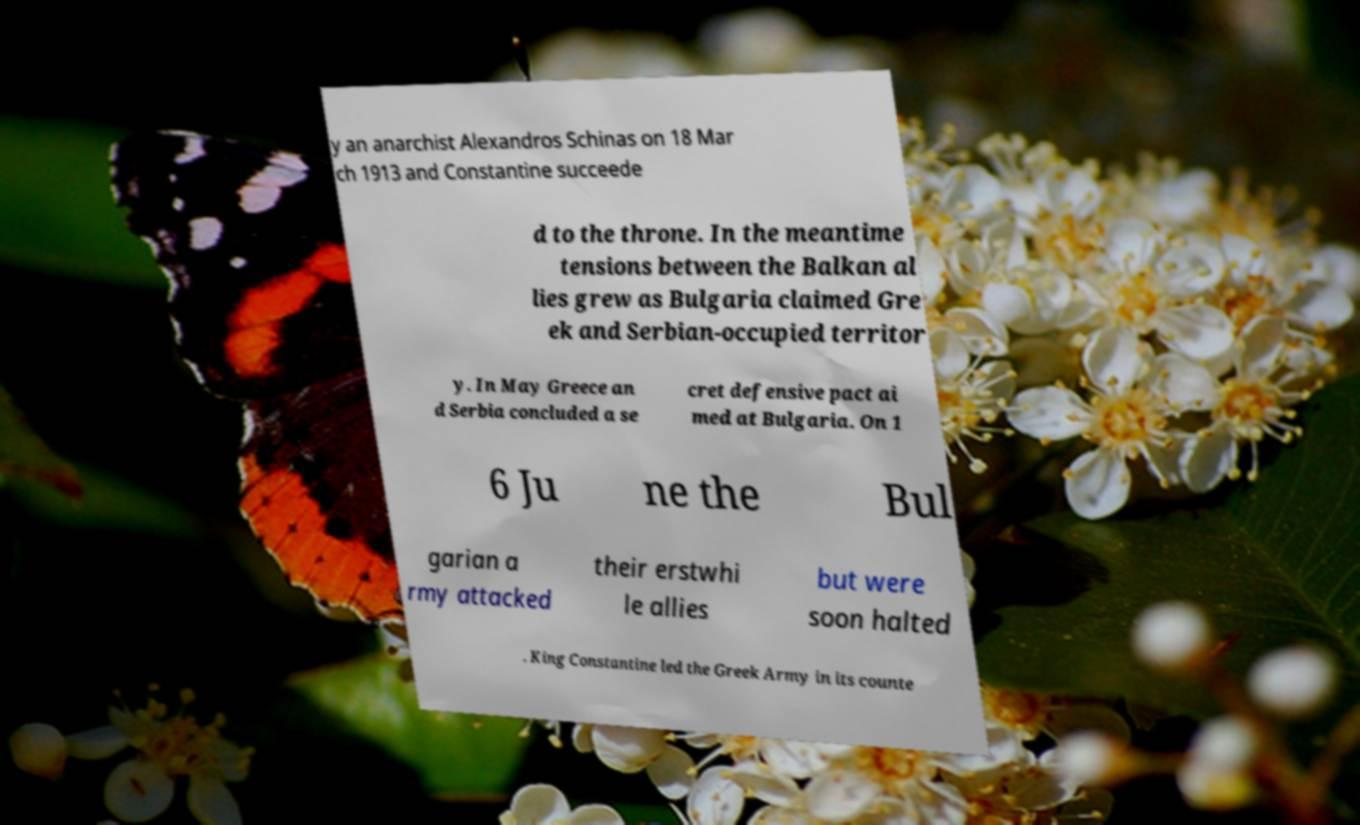For documentation purposes, I need the text within this image transcribed. Could you provide that? y an anarchist Alexandros Schinas on 18 Mar ch 1913 and Constantine succeede d to the throne. In the meantime tensions between the Balkan al lies grew as Bulgaria claimed Gre ek and Serbian-occupied territor y. In May Greece an d Serbia concluded a se cret defensive pact ai med at Bulgaria. On 1 6 Ju ne the Bul garian a rmy attacked their erstwhi le allies but were soon halted . King Constantine led the Greek Army in its counte 